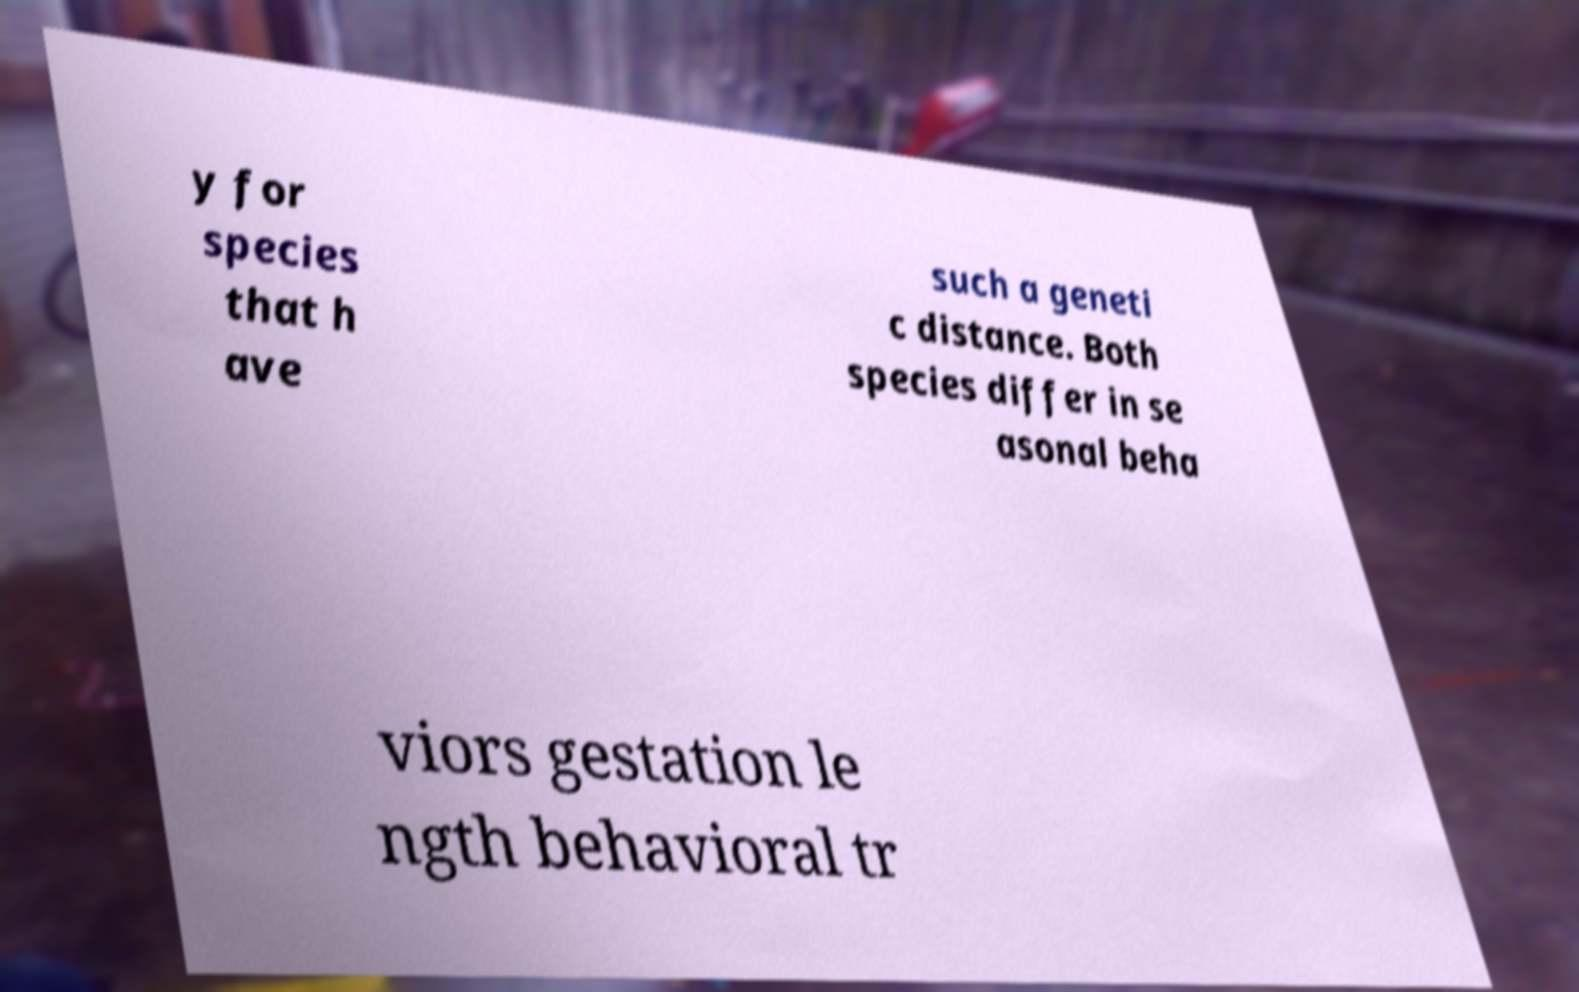For documentation purposes, I need the text within this image transcribed. Could you provide that? y for species that h ave such a geneti c distance. Both species differ in se asonal beha viors gestation le ngth behavioral tr 